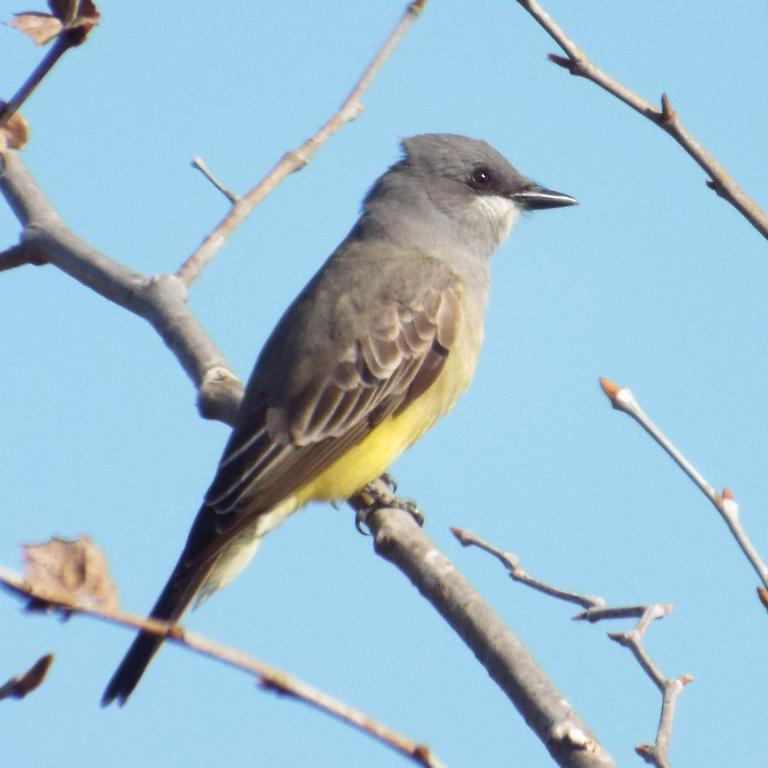What type of plant is depicted in the image? There are stems of a tree in the image. Are there any animals present in the image? Yes, there is a black and yellow colored bird on the tree. What can be seen on the left side of the image? There are leaves on the left side of the image. What is visible in the background of the image? The sky is visible in the background of the image. What type of crime is being committed in the image? There is no indication of any crime being committed in the image; it features a tree with a bird and leaves. What type of vest is the tree wearing in the image? Trees do not wear vests, so this question is not applicable to the image. 